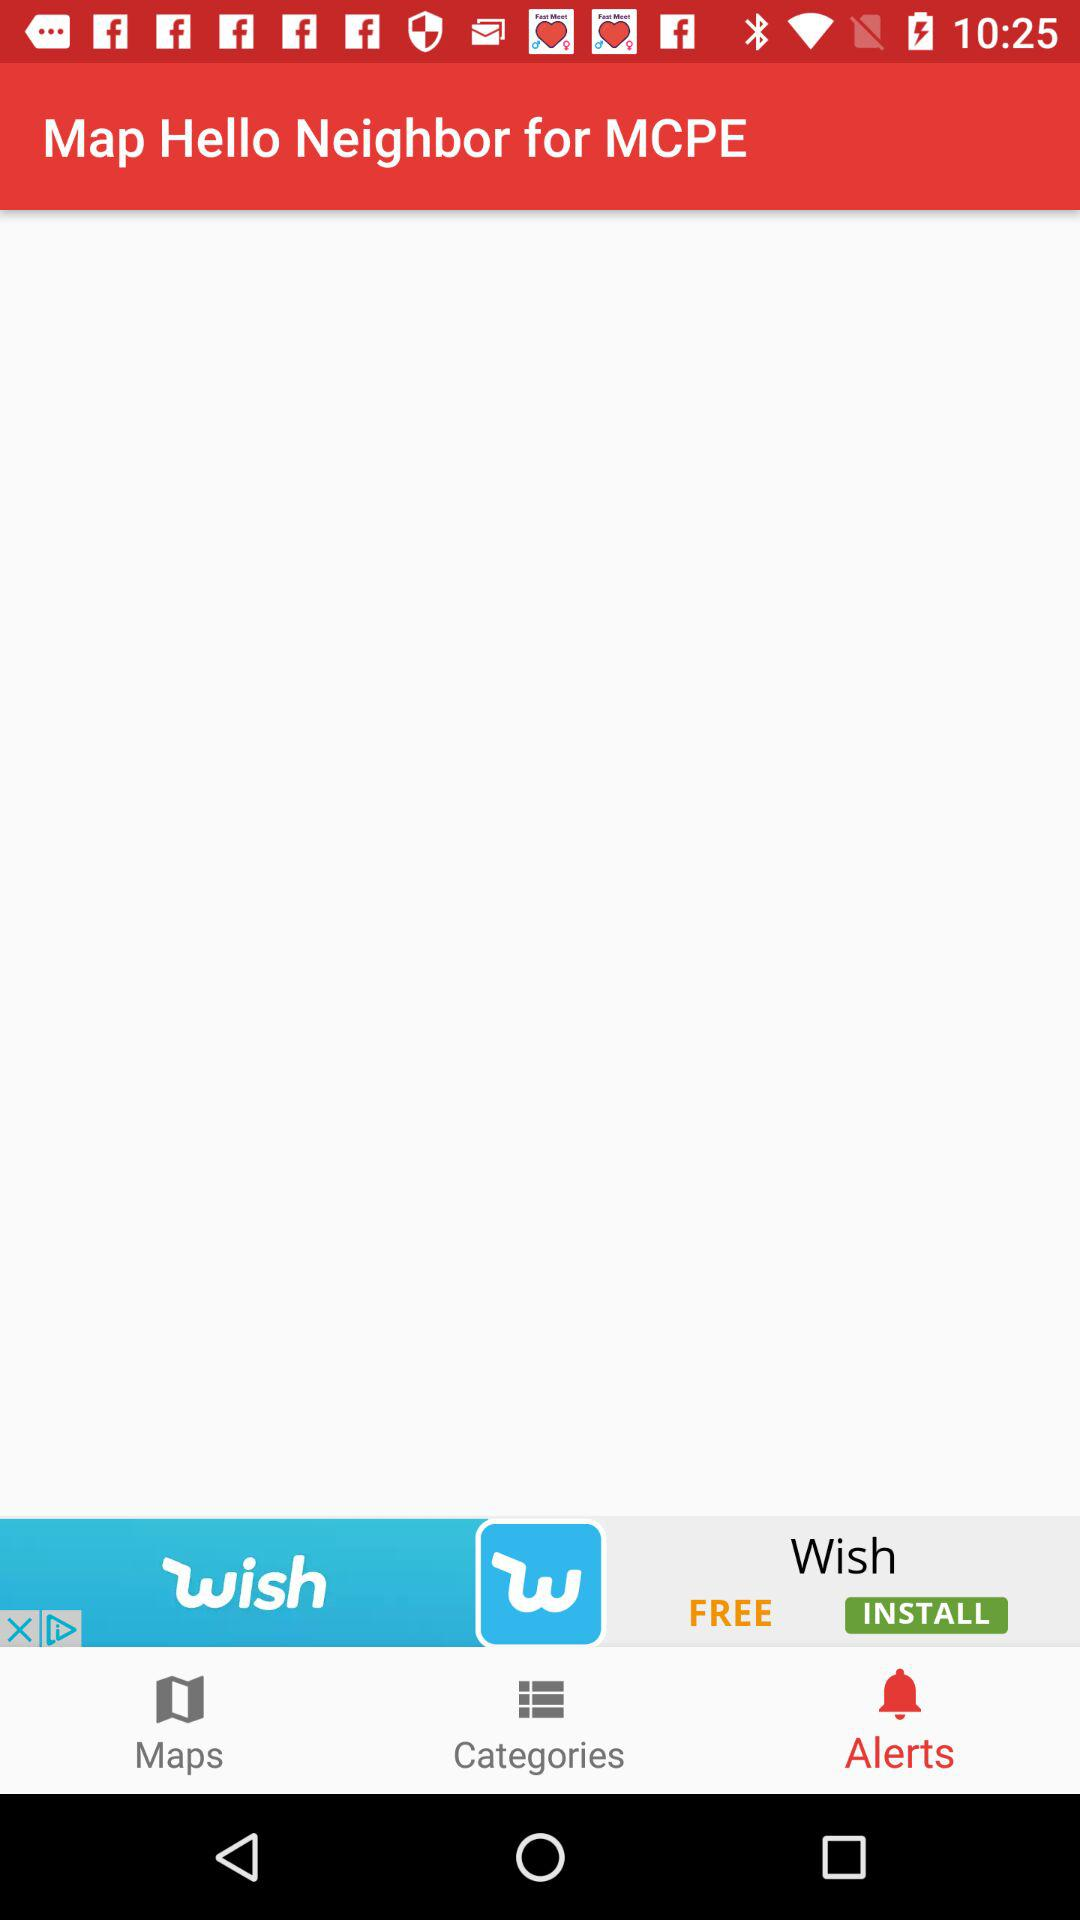Which tab is selected? The selected tab is "Alerts". 